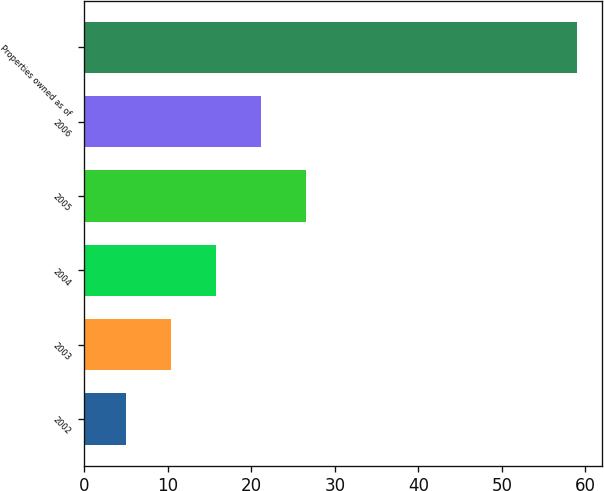Convert chart. <chart><loc_0><loc_0><loc_500><loc_500><bar_chart><fcel>2002<fcel>2003<fcel>2004<fcel>2005<fcel>2006<fcel>Properties owned as of<nl><fcel>5<fcel>10.4<fcel>15.8<fcel>26.6<fcel>21.2<fcel>59<nl></chart> 